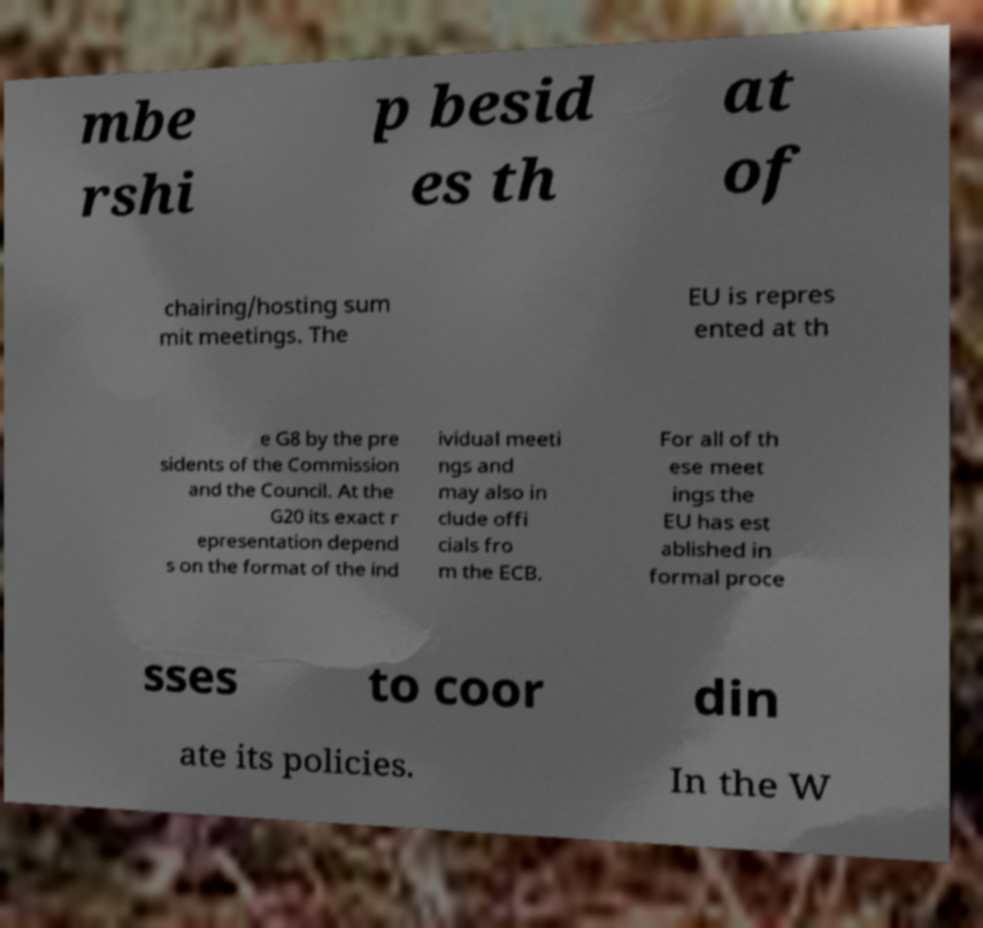For documentation purposes, I need the text within this image transcribed. Could you provide that? mbe rshi p besid es th at of chairing/hosting sum mit meetings. The EU is repres ented at th e G8 by the pre sidents of the Commission and the Council. At the G20 its exact r epresentation depend s on the format of the ind ividual meeti ngs and may also in clude offi cials fro m the ECB. For all of th ese meet ings the EU has est ablished in formal proce sses to coor din ate its policies. In the W 